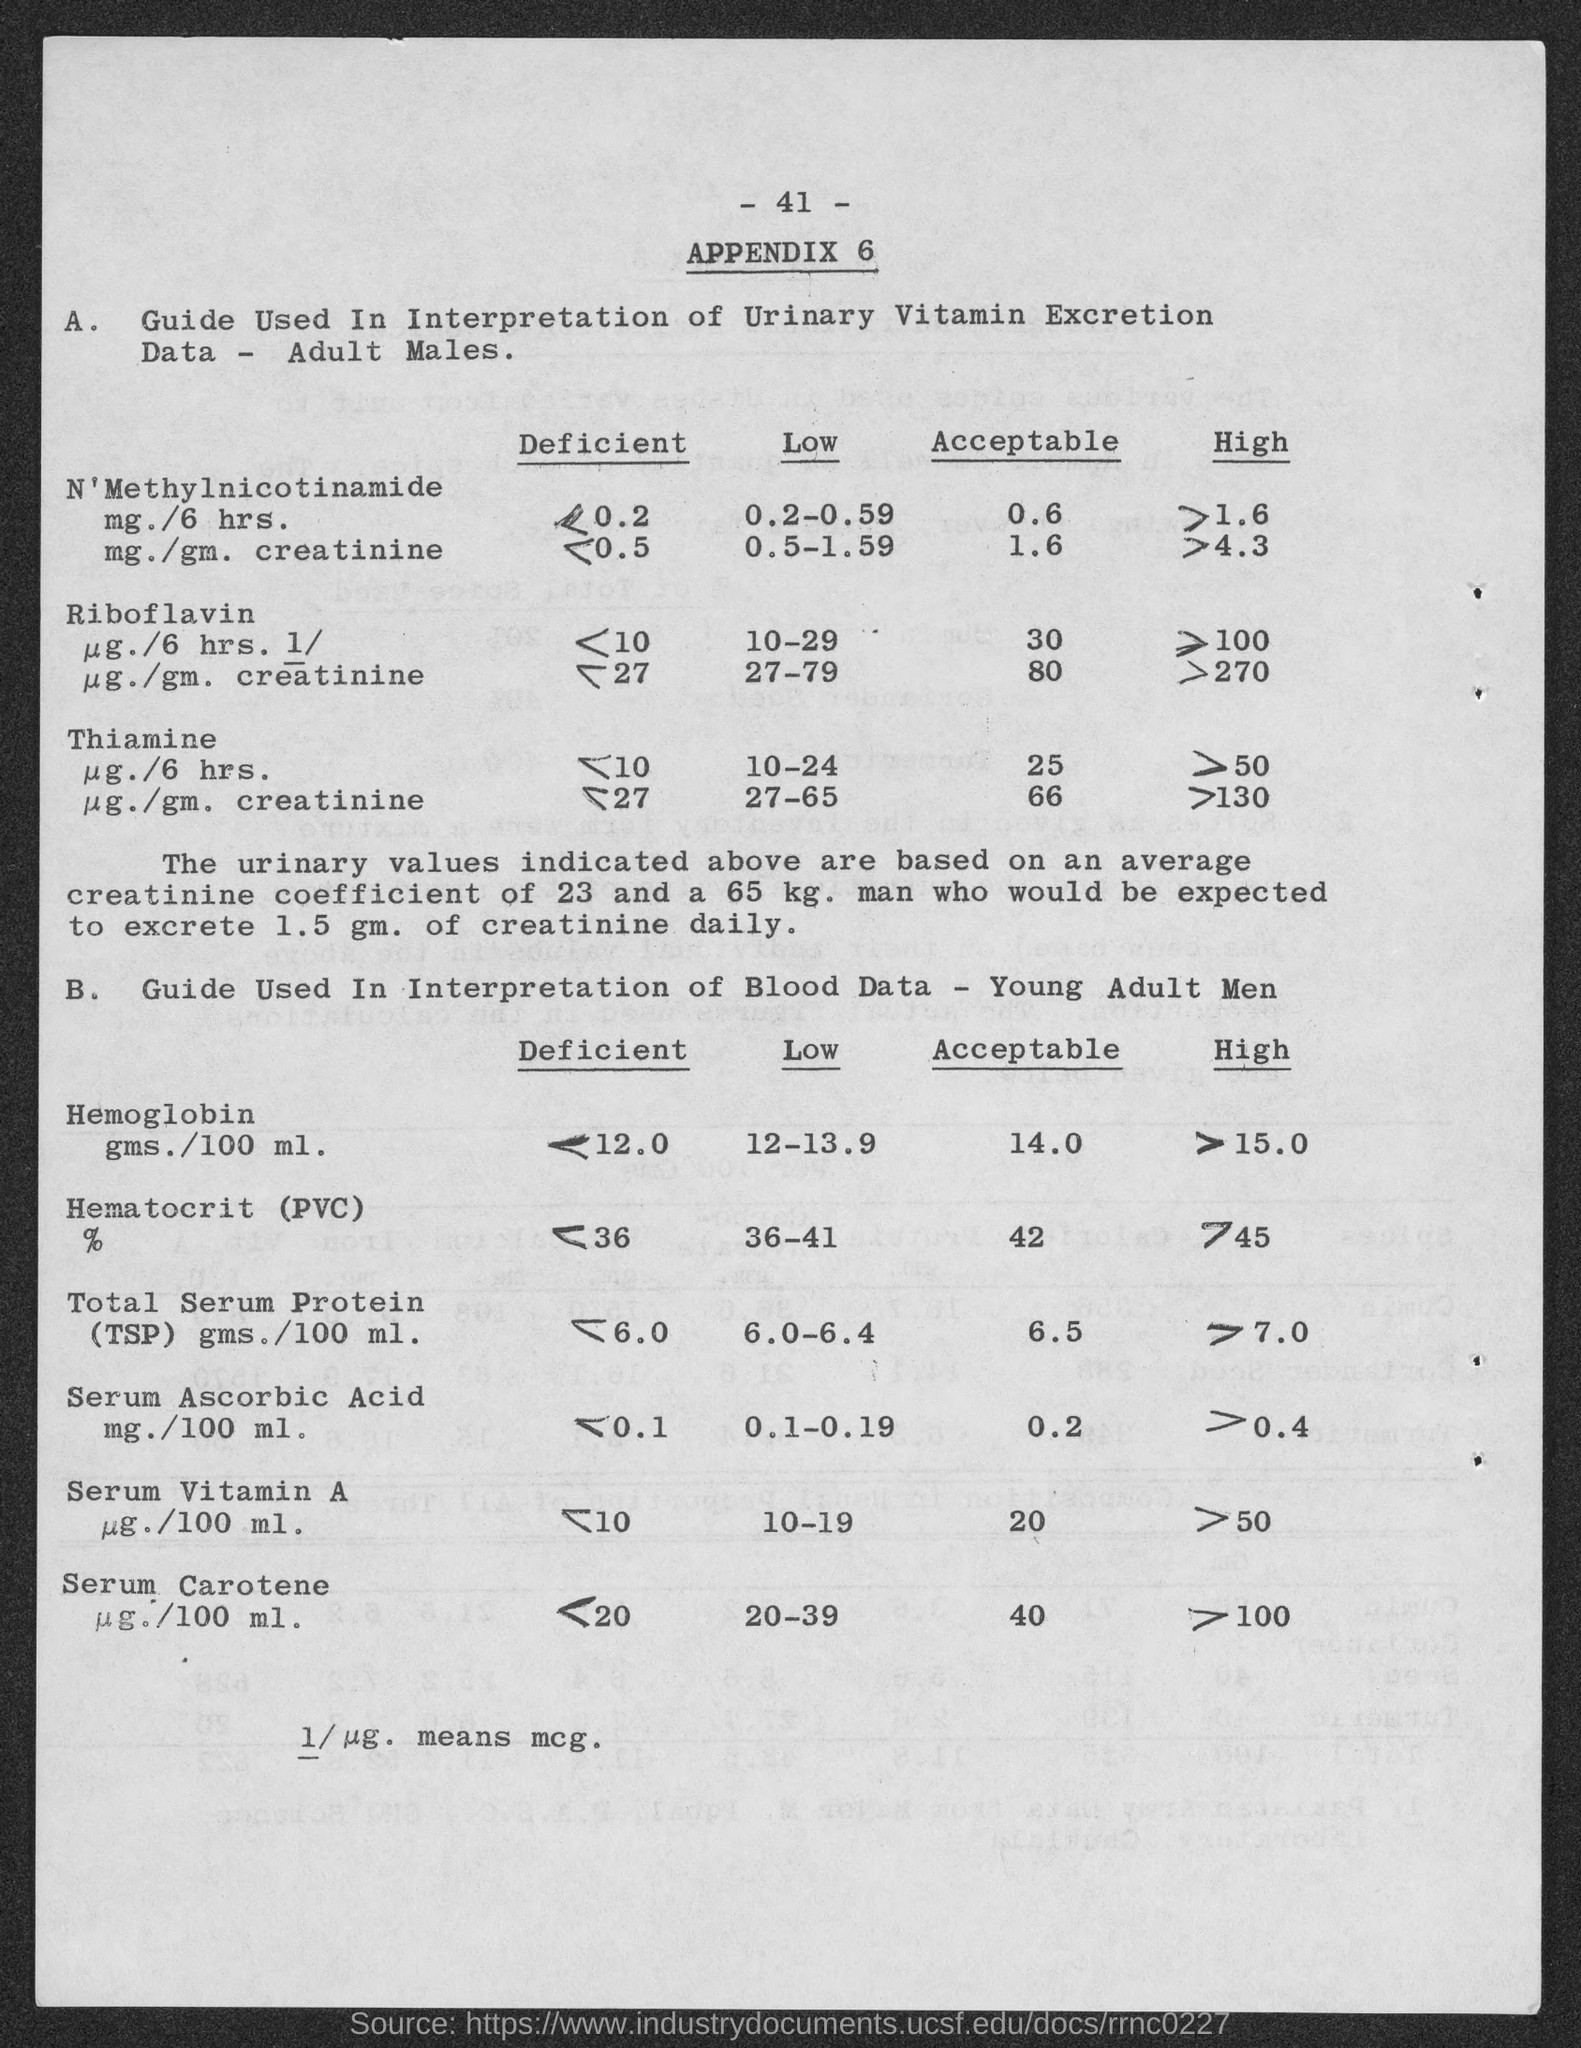What is the Acceptable Range of Hemoglobin for Young Adult Men?
Your response must be concise. 14.0. Low Range of Serum Ascorbic Acid?
Your answer should be compact. 0.1-0.19. What is the meaning of 1/ug?
Your answer should be compact. Mcg. 